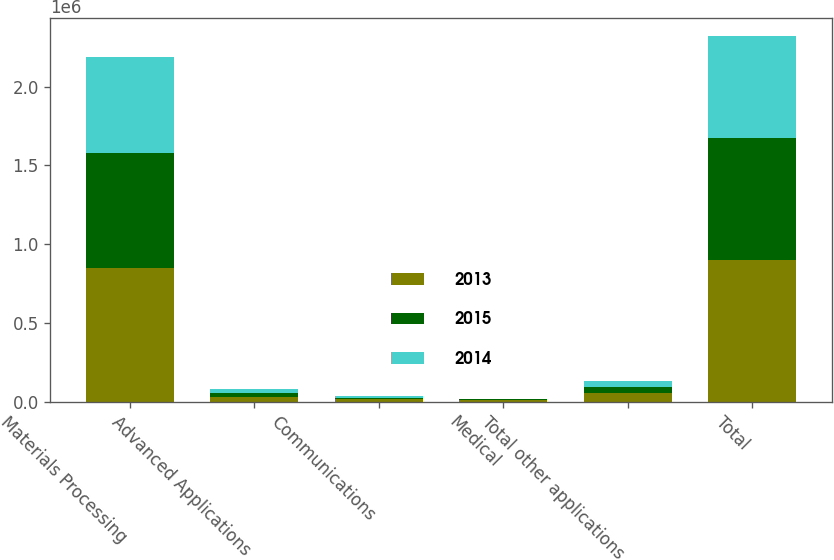Convert chart to OTSL. <chart><loc_0><loc_0><loc_500><loc_500><stacked_bar_chart><ecel><fcel>Materials Processing<fcel>Advanced Applications<fcel>Communications<fcel>Medical<fcel>Total other applications<fcel>Total<nl><fcel>2013<fcel>849335<fcel>28866<fcel>14399<fcel>8665<fcel>51931<fcel>901265<nl><fcel>2015<fcel>731274<fcel>25704<fcel>8523<fcel>4331<fcel>38558<fcel>769832<nl><fcel>2014<fcel>608702<fcel>26190<fcel>9135<fcel>4007<fcel>39332<fcel>648034<nl></chart> 